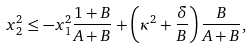Convert formula to latex. <formula><loc_0><loc_0><loc_500><loc_500>x _ { 2 } ^ { 2 } \leq - x _ { 1 } ^ { 2 } \frac { 1 + B } { A + B } + \left ( \kappa ^ { 2 } + \frac { \delta } { B } \right ) \frac { B } { A + B } ,</formula> 